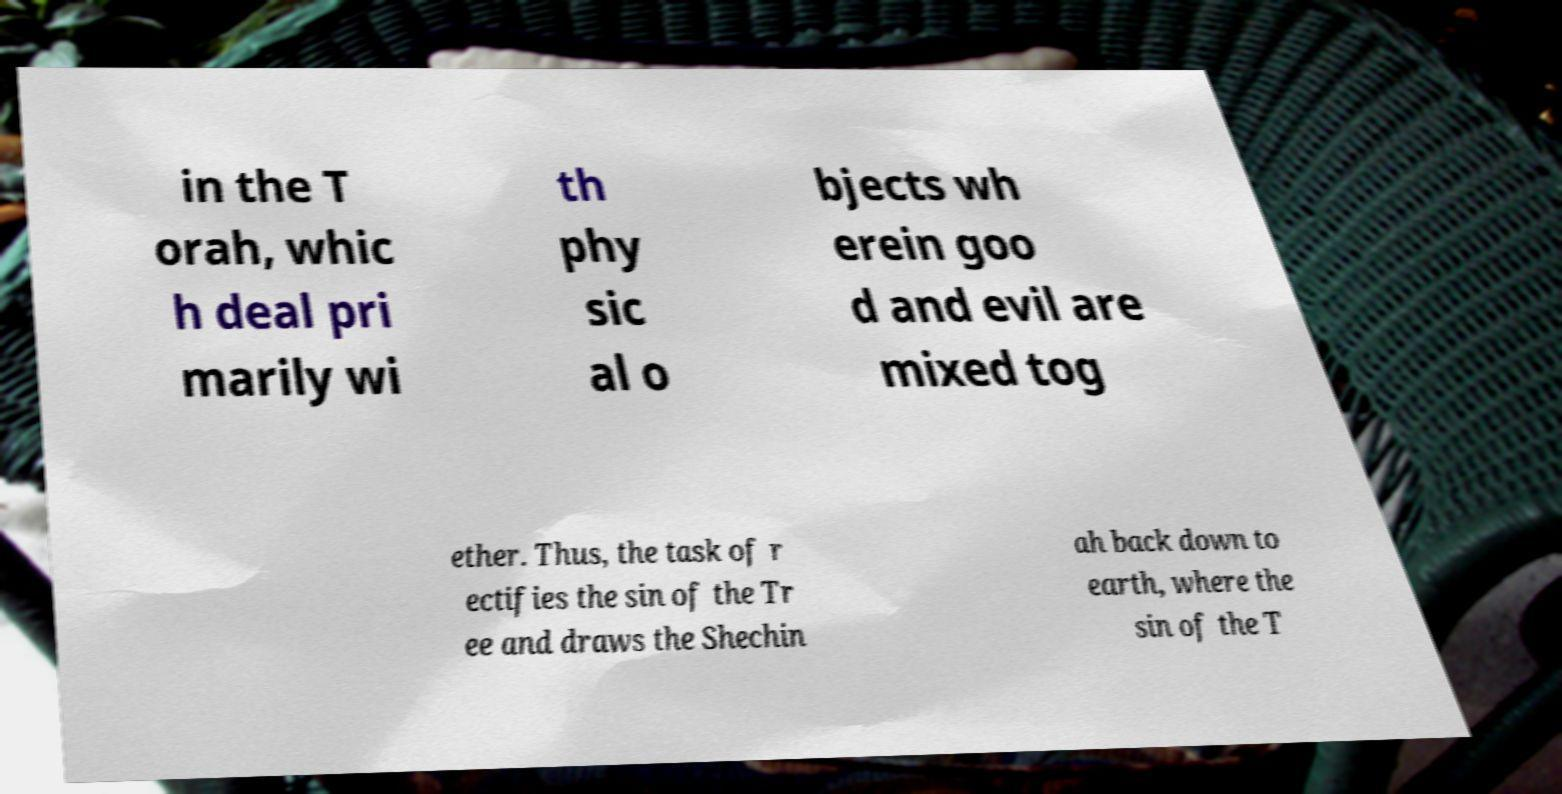For documentation purposes, I need the text within this image transcribed. Could you provide that? in the T orah, whic h deal pri marily wi th phy sic al o bjects wh erein goo d and evil are mixed tog ether. Thus, the task of r ectifies the sin of the Tr ee and draws the Shechin ah back down to earth, where the sin of the T 